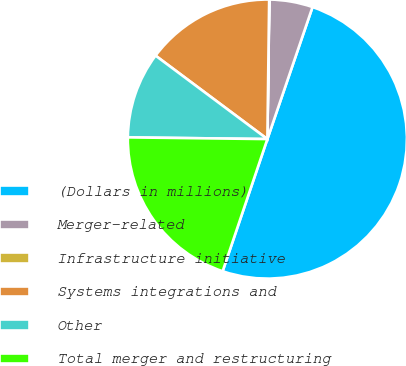Convert chart to OTSL. <chart><loc_0><loc_0><loc_500><loc_500><pie_chart><fcel>(Dollars in millions)<fcel>Merger-related<fcel>Infrastructure initiative<fcel>Systems integrations and<fcel>Other<fcel>Total merger and restructuring<nl><fcel>49.95%<fcel>5.02%<fcel>0.02%<fcel>15.0%<fcel>10.01%<fcel>20.0%<nl></chart> 